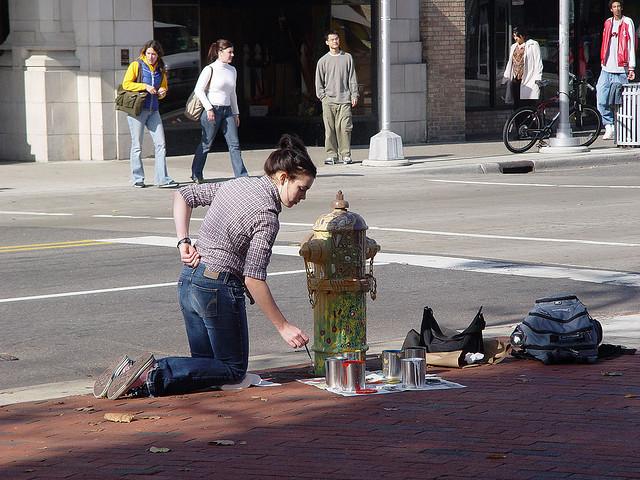What is the lady painting?
Short answer required. Fire hydrant. What color is the backpack on the ground?
Quick response, please. Gray. What type of art is being created?
Short answer required. Painting. Is the girl adjusting her pants?
Keep it brief. Yes. Is the girl sitting on the sidewalk?
Be succinct. No. 